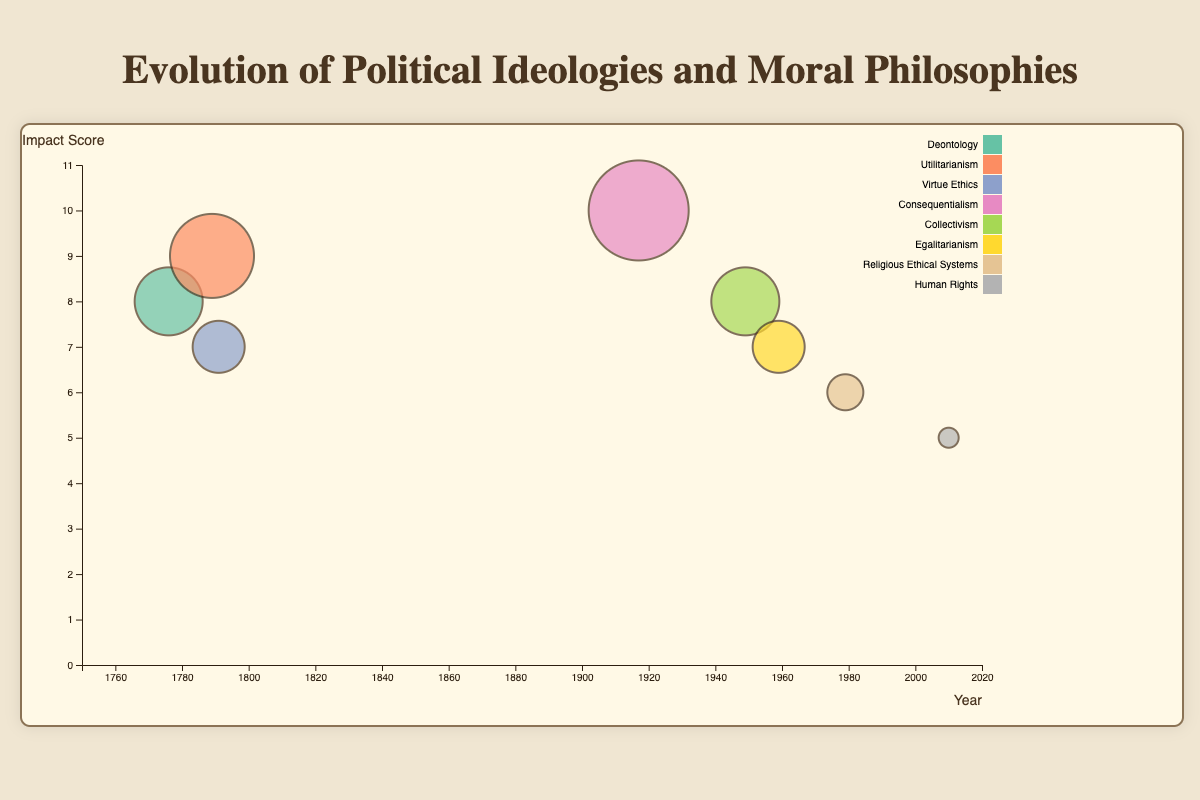What's the title of the figure? The title is displayed at the top central part of the chart, it clearly states the theme of the visualization.
Answer: Evolution of Political Ideologies and Moral Philosophies How many revolutions are represented in the chart? Each bubble represents a revolution, and by counting them, we find the total number.
Answer: Eight During which revolution did the concept of "Virtue Ethics" play a significant role, and what was its impact score? By checking the legend for "Virtue Ethics" and finding the corresponding bubble, we can identify both the revolution and the impact score mentioned in the tooltip.
Answer: Haitian Revolution, Impact Score of 7 Which revolution occurred closest to the year 1800? By examining the x-axis for the year closest to 1800 and matching it to the corresponding bubble, we identify the revolution.
Answer: Haitian Revolution (1791) What is the moral philosophy associated with the highest impact score? By locating the largest bubble (highest impact score) on the chart and checking the tooltip, we identify the corresponding moral philosophy.
Answer: Consequentialism (Russian Revolution) What is the average impact score of revolutions that occurred before the 20th century? The revolutions before the 20th century are the American, French, and Haitian Revolutions. Their impact scores are 8, 9, and 7, respectively. The average is calculated as (8 + 9 + 7) / 3.
Answer: 8 Which revolution with a moral philosophy focused on "Human Rights" has the lowest impact score, and what is that score? Finding the bubble labeled "Human Rights" and checking the tooltip for its impact score allows us to identify the revolution and score.
Answer: Arab Spring, Impact Score of 5 Compare the impact scores between the American Revolution and the Cuban Revolution. Which one had a higher score? Checking the bubbles for the American Revolution and the Cuban Revolution, we compare their impact scores of 8 and 7, respectively.
Answer: American Revolution Which political ideology is linked to the French Revolution, and what is unique about its moral philosophy compared to the American Revolution's? The tooltip for the French Revolution indicates its political ideology is Republicanism. Its moral philosophy is Utilitarianism, compared to Deontology for the American Revolution. This reflects a shift from rule-based ethics to outcome-based ethics.
Answer: Republicanism, Utilitarianism vs. Deontology How does the size of the bubble relate to the impact score, and which revolution has the second-largest bubble? The size of the bubble increases with higher impact scores. The second-largest bubble represents the revolution with the second-highest impact score.
Answer: French Revolution (Impact Score of 9) 